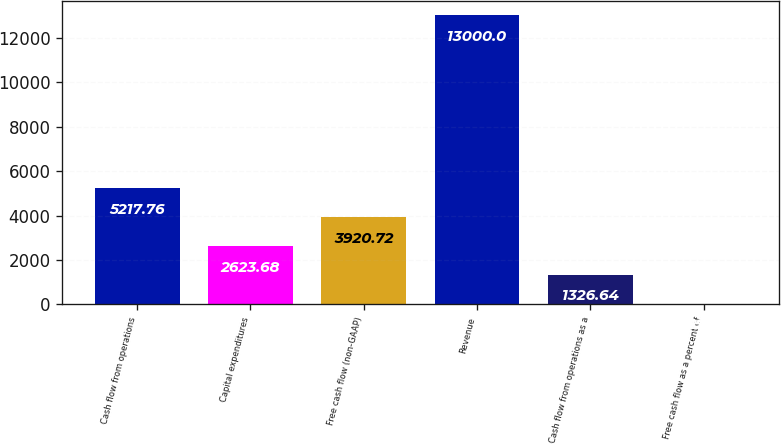Convert chart to OTSL. <chart><loc_0><loc_0><loc_500><loc_500><bar_chart><fcel>Cash flow from operations<fcel>Capital expenditures<fcel>Free cash flow (non-GAAP)<fcel>Revenue<fcel>Cash flow from operations as a<fcel>Free cash flow as a percent of<nl><fcel>5217.76<fcel>2623.68<fcel>3920.72<fcel>13000<fcel>1326.64<fcel>29.6<nl></chart> 